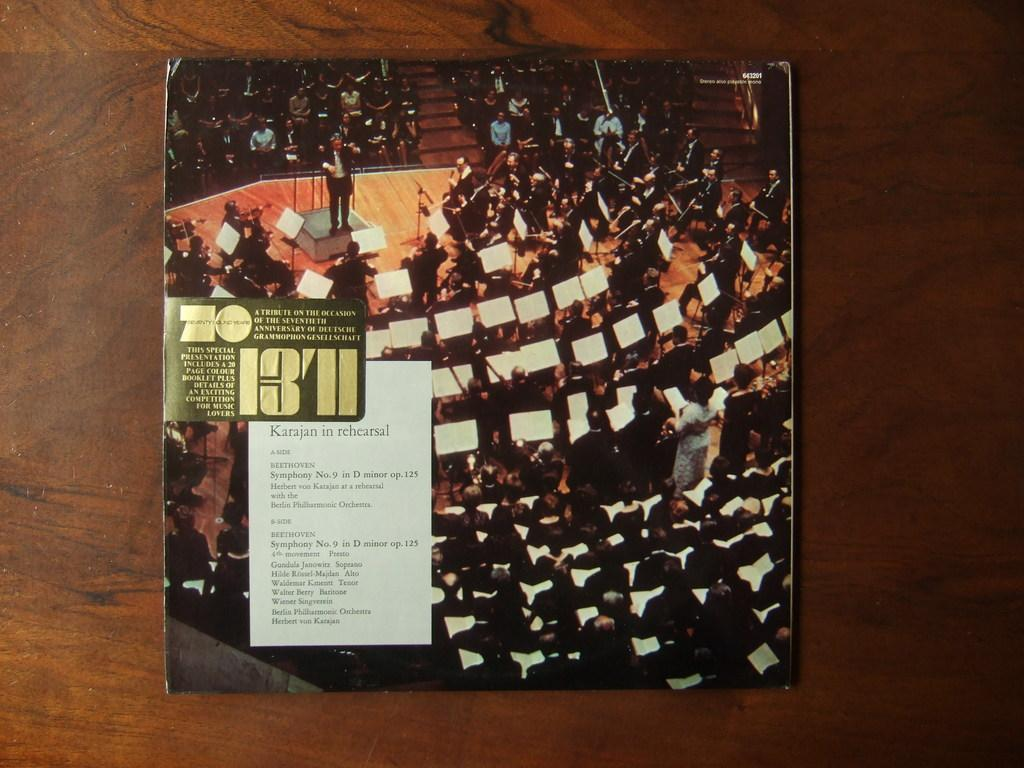<image>
Describe the image concisely. An album cover with the numbers 1371 on the front. 